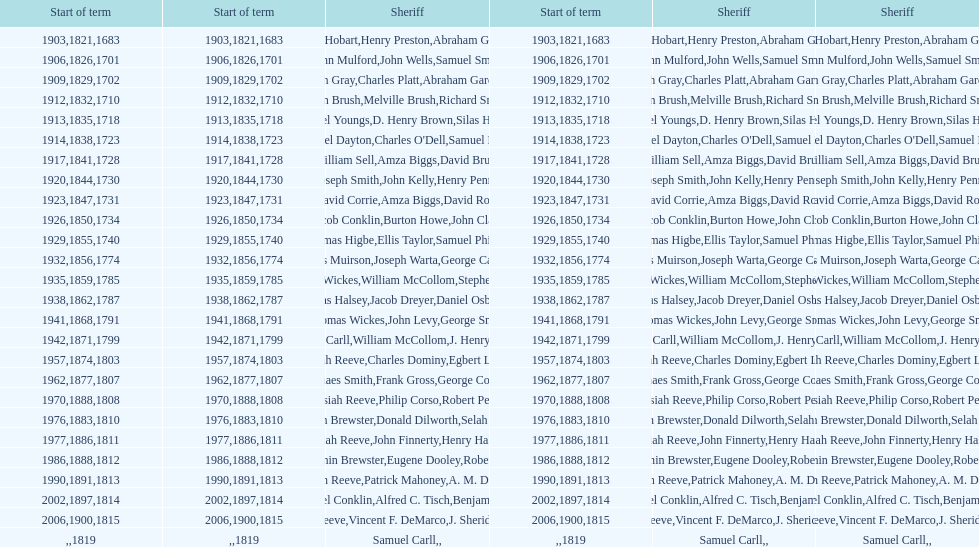When did benjamin brewster serve his second term? 1812. 